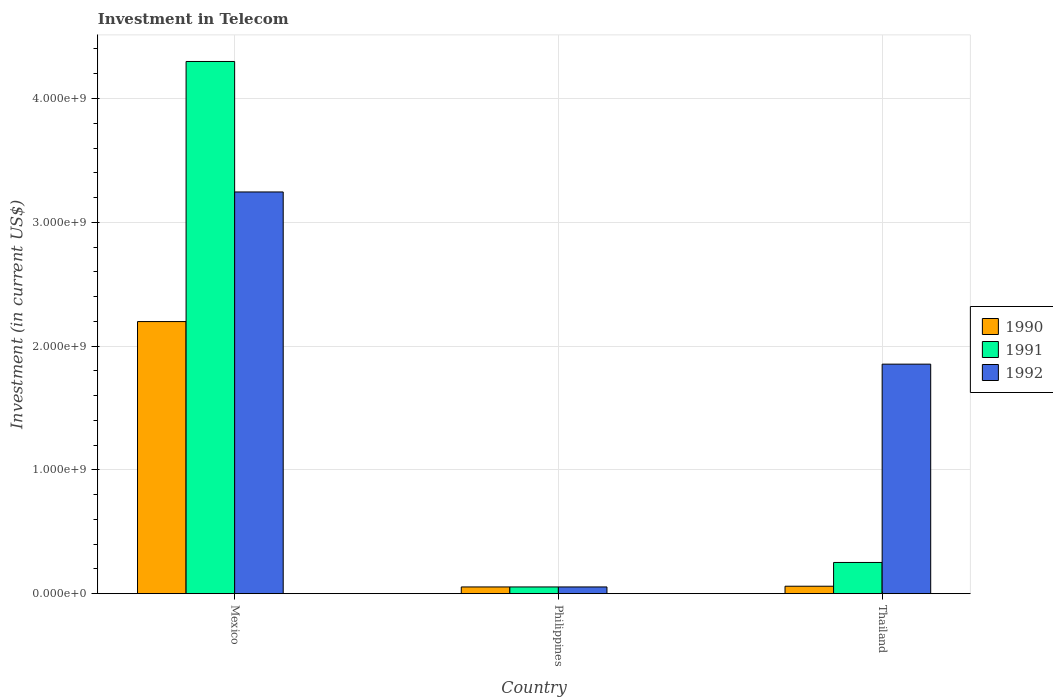How many different coloured bars are there?
Make the answer very short. 3. What is the label of the 2nd group of bars from the left?
Your answer should be very brief. Philippines. What is the amount invested in telecom in 1992 in Thailand?
Your answer should be compact. 1.85e+09. Across all countries, what is the maximum amount invested in telecom in 1990?
Provide a succinct answer. 2.20e+09. Across all countries, what is the minimum amount invested in telecom in 1992?
Ensure brevity in your answer.  5.42e+07. In which country was the amount invested in telecom in 1991 maximum?
Provide a succinct answer. Mexico. What is the total amount invested in telecom in 1991 in the graph?
Offer a terse response. 4.61e+09. What is the difference between the amount invested in telecom in 1991 in Mexico and that in Philippines?
Offer a very short reply. 4.24e+09. What is the difference between the amount invested in telecom in 1990 in Mexico and the amount invested in telecom in 1991 in Philippines?
Your answer should be very brief. 2.14e+09. What is the average amount invested in telecom in 1990 per country?
Ensure brevity in your answer.  7.71e+08. What is the difference between the amount invested in telecom of/in 1991 and amount invested in telecom of/in 1990 in Thailand?
Provide a short and direct response. 1.92e+08. What is the ratio of the amount invested in telecom in 1992 in Mexico to that in Thailand?
Your response must be concise. 1.75. Is the difference between the amount invested in telecom in 1991 in Philippines and Thailand greater than the difference between the amount invested in telecom in 1990 in Philippines and Thailand?
Provide a short and direct response. No. What is the difference between the highest and the second highest amount invested in telecom in 1991?
Provide a short and direct response. 4.05e+09. What is the difference between the highest and the lowest amount invested in telecom in 1992?
Give a very brief answer. 3.19e+09. In how many countries, is the amount invested in telecom in 1991 greater than the average amount invested in telecom in 1991 taken over all countries?
Your answer should be very brief. 1. What does the 3rd bar from the right in Thailand represents?
Provide a succinct answer. 1990. Are all the bars in the graph horizontal?
Your answer should be very brief. No. How many countries are there in the graph?
Your response must be concise. 3. What is the difference between two consecutive major ticks on the Y-axis?
Provide a succinct answer. 1.00e+09. Does the graph contain grids?
Offer a very short reply. Yes. Where does the legend appear in the graph?
Provide a succinct answer. Center right. How many legend labels are there?
Offer a terse response. 3. How are the legend labels stacked?
Offer a terse response. Vertical. What is the title of the graph?
Make the answer very short. Investment in Telecom. Does "2003" appear as one of the legend labels in the graph?
Provide a short and direct response. No. What is the label or title of the Y-axis?
Your answer should be very brief. Investment (in current US$). What is the Investment (in current US$) of 1990 in Mexico?
Give a very brief answer. 2.20e+09. What is the Investment (in current US$) of 1991 in Mexico?
Offer a very short reply. 4.30e+09. What is the Investment (in current US$) of 1992 in Mexico?
Offer a very short reply. 3.24e+09. What is the Investment (in current US$) in 1990 in Philippines?
Make the answer very short. 5.42e+07. What is the Investment (in current US$) in 1991 in Philippines?
Your answer should be very brief. 5.42e+07. What is the Investment (in current US$) in 1992 in Philippines?
Your answer should be compact. 5.42e+07. What is the Investment (in current US$) in 1990 in Thailand?
Offer a very short reply. 6.00e+07. What is the Investment (in current US$) in 1991 in Thailand?
Provide a succinct answer. 2.52e+08. What is the Investment (in current US$) in 1992 in Thailand?
Your answer should be very brief. 1.85e+09. Across all countries, what is the maximum Investment (in current US$) in 1990?
Ensure brevity in your answer.  2.20e+09. Across all countries, what is the maximum Investment (in current US$) in 1991?
Ensure brevity in your answer.  4.30e+09. Across all countries, what is the maximum Investment (in current US$) in 1992?
Provide a short and direct response. 3.24e+09. Across all countries, what is the minimum Investment (in current US$) of 1990?
Your answer should be very brief. 5.42e+07. Across all countries, what is the minimum Investment (in current US$) in 1991?
Ensure brevity in your answer.  5.42e+07. Across all countries, what is the minimum Investment (in current US$) in 1992?
Provide a short and direct response. 5.42e+07. What is the total Investment (in current US$) in 1990 in the graph?
Your answer should be compact. 2.31e+09. What is the total Investment (in current US$) of 1991 in the graph?
Offer a very short reply. 4.61e+09. What is the total Investment (in current US$) in 1992 in the graph?
Give a very brief answer. 5.15e+09. What is the difference between the Investment (in current US$) in 1990 in Mexico and that in Philippines?
Provide a succinct answer. 2.14e+09. What is the difference between the Investment (in current US$) in 1991 in Mexico and that in Philippines?
Provide a short and direct response. 4.24e+09. What is the difference between the Investment (in current US$) of 1992 in Mexico and that in Philippines?
Your response must be concise. 3.19e+09. What is the difference between the Investment (in current US$) in 1990 in Mexico and that in Thailand?
Your answer should be compact. 2.14e+09. What is the difference between the Investment (in current US$) of 1991 in Mexico and that in Thailand?
Provide a short and direct response. 4.05e+09. What is the difference between the Investment (in current US$) of 1992 in Mexico and that in Thailand?
Ensure brevity in your answer.  1.39e+09. What is the difference between the Investment (in current US$) of 1990 in Philippines and that in Thailand?
Keep it short and to the point. -5.80e+06. What is the difference between the Investment (in current US$) of 1991 in Philippines and that in Thailand?
Make the answer very short. -1.98e+08. What is the difference between the Investment (in current US$) of 1992 in Philippines and that in Thailand?
Keep it short and to the point. -1.80e+09. What is the difference between the Investment (in current US$) of 1990 in Mexico and the Investment (in current US$) of 1991 in Philippines?
Provide a succinct answer. 2.14e+09. What is the difference between the Investment (in current US$) in 1990 in Mexico and the Investment (in current US$) in 1992 in Philippines?
Your response must be concise. 2.14e+09. What is the difference between the Investment (in current US$) of 1991 in Mexico and the Investment (in current US$) of 1992 in Philippines?
Make the answer very short. 4.24e+09. What is the difference between the Investment (in current US$) of 1990 in Mexico and the Investment (in current US$) of 1991 in Thailand?
Provide a short and direct response. 1.95e+09. What is the difference between the Investment (in current US$) of 1990 in Mexico and the Investment (in current US$) of 1992 in Thailand?
Give a very brief answer. 3.44e+08. What is the difference between the Investment (in current US$) of 1991 in Mexico and the Investment (in current US$) of 1992 in Thailand?
Ensure brevity in your answer.  2.44e+09. What is the difference between the Investment (in current US$) in 1990 in Philippines and the Investment (in current US$) in 1991 in Thailand?
Offer a very short reply. -1.98e+08. What is the difference between the Investment (in current US$) in 1990 in Philippines and the Investment (in current US$) in 1992 in Thailand?
Keep it short and to the point. -1.80e+09. What is the difference between the Investment (in current US$) of 1991 in Philippines and the Investment (in current US$) of 1992 in Thailand?
Your answer should be very brief. -1.80e+09. What is the average Investment (in current US$) in 1990 per country?
Your response must be concise. 7.71e+08. What is the average Investment (in current US$) of 1991 per country?
Keep it short and to the point. 1.54e+09. What is the average Investment (in current US$) in 1992 per country?
Your response must be concise. 1.72e+09. What is the difference between the Investment (in current US$) of 1990 and Investment (in current US$) of 1991 in Mexico?
Your answer should be very brief. -2.10e+09. What is the difference between the Investment (in current US$) in 1990 and Investment (in current US$) in 1992 in Mexico?
Ensure brevity in your answer.  -1.05e+09. What is the difference between the Investment (in current US$) of 1991 and Investment (in current US$) of 1992 in Mexico?
Your response must be concise. 1.05e+09. What is the difference between the Investment (in current US$) of 1991 and Investment (in current US$) of 1992 in Philippines?
Provide a succinct answer. 0. What is the difference between the Investment (in current US$) of 1990 and Investment (in current US$) of 1991 in Thailand?
Offer a very short reply. -1.92e+08. What is the difference between the Investment (in current US$) of 1990 and Investment (in current US$) of 1992 in Thailand?
Keep it short and to the point. -1.79e+09. What is the difference between the Investment (in current US$) in 1991 and Investment (in current US$) in 1992 in Thailand?
Keep it short and to the point. -1.60e+09. What is the ratio of the Investment (in current US$) of 1990 in Mexico to that in Philippines?
Make the answer very short. 40.55. What is the ratio of the Investment (in current US$) of 1991 in Mexico to that in Philippines?
Provide a short and direct response. 79.32. What is the ratio of the Investment (in current US$) in 1992 in Mexico to that in Philippines?
Make the answer very short. 59.87. What is the ratio of the Investment (in current US$) of 1990 in Mexico to that in Thailand?
Keep it short and to the point. 36.63. What is the ratio of the Investment (in current US$) of 1991 in Mexico to that in Thailand?
Your answer should be very brief. 17.06. What is the ratio of the Investment (in current US$) in 1992 in Mexico to that in Thailand?
Give a very brief answer. 1.75. What is the ratio of the Investment (in current US$) of 1990 in Philippines to that in Thailand?
Your answer should be compact. 0.9. What is the ratio of the Investment (in current US$) in 1991 in Philippines to that in Thailand?
Provide a short and direct response. 0.22. What is the ratio of the Investment (in current US$) of 1992 in Philippines to that in Thailand?
Keep it short and to the point. 0.03. What is the difference between the highest and the second highest Investment (in current US$) in 1990?
Provide a succinct answer. 2.14e+09. What is the difference between the highest and the second highest Investment (in current US$) in 1991?
Your answer should be very brief. 4.05e+09. What is the difference between the highest and the second highest Investment (in current US$) in 1992?
Give a very brief answer. 1.39e+09. What is the difference between the highest and the lowest Investment (in current US$) in 1990?
Keep it short and to the point. 2.14e+09. What is the difference between the highest and the lowest Investment (in current US$) in 1991?
Provide a succinct answer. 4.24e+09. What is the difference between the highest and the lowest Investment (in current US$) in 1992?
Provide a succinct answer. 3.19e+09. 